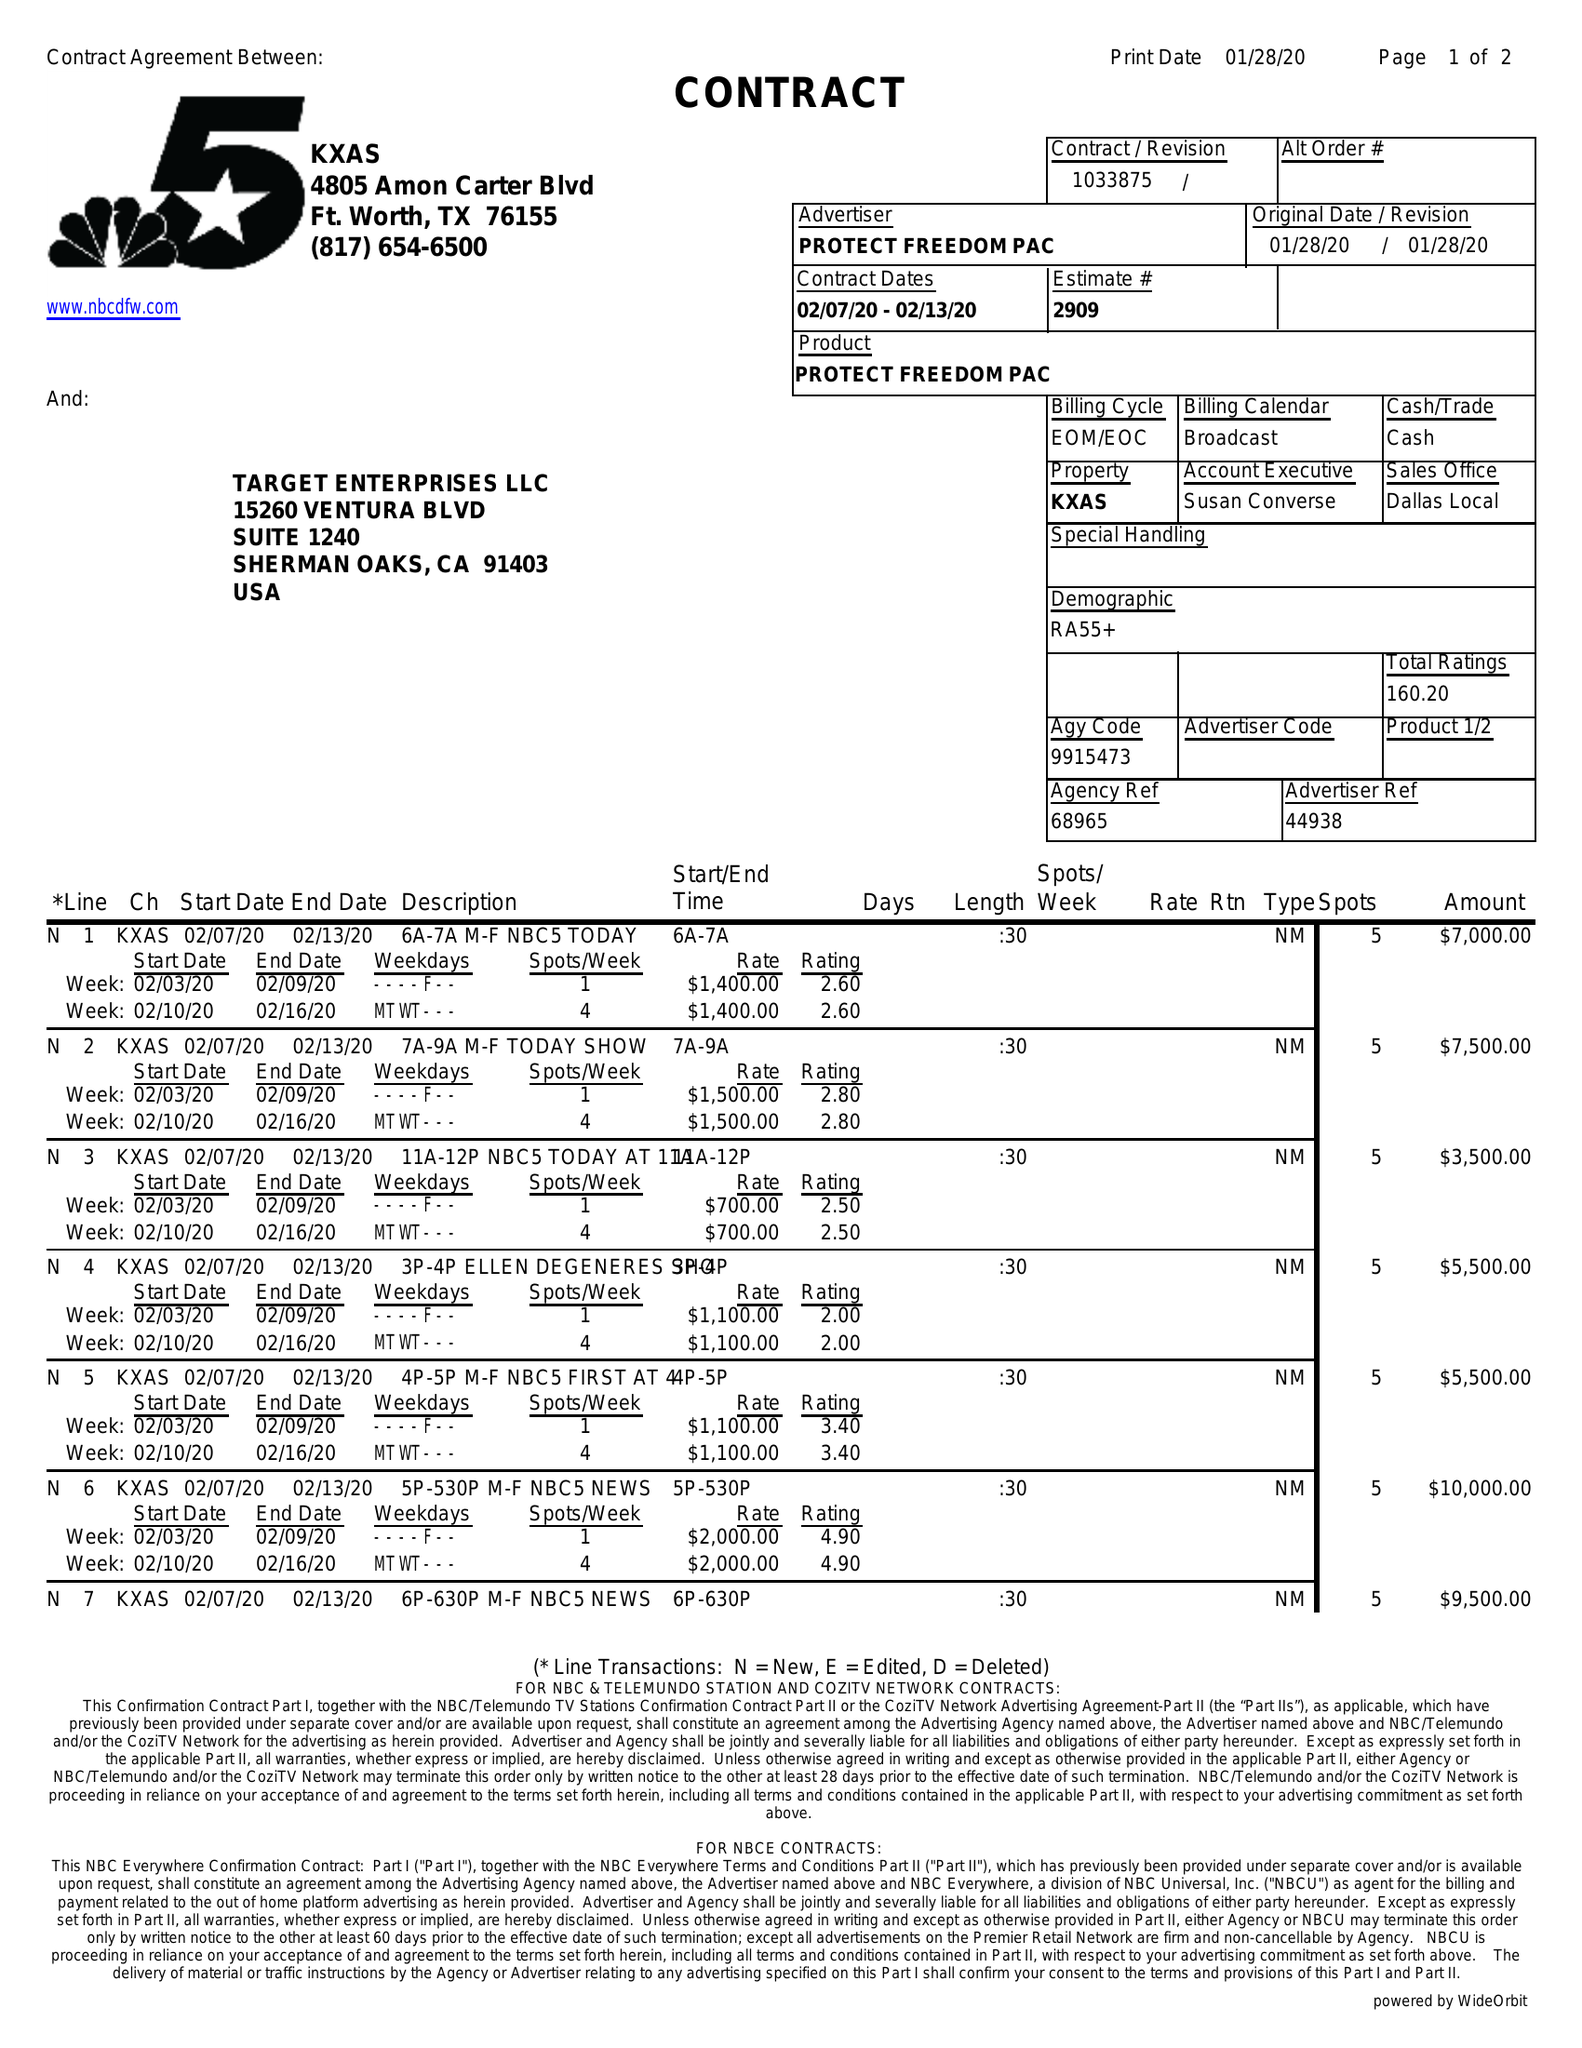What is the value for the flight_to?
Answer the question using a single word or phrase. 02/13/20 